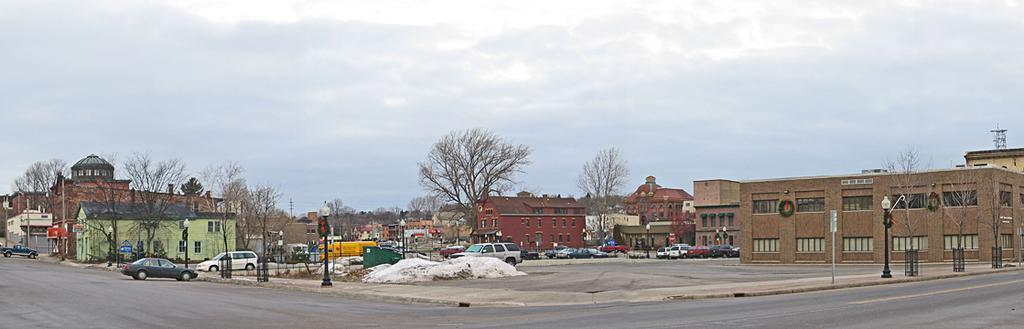What type of structures are present in the image? There are street lights, poles, vehicles, trees, buildings, and a road visible in the image. What can be seen in the sky in the image? The sky is cloudy in the image. Can you see a shoe on the journey of the bee in the image? There is no bee or journey involving a bee in the image, and no shoe is visible. 